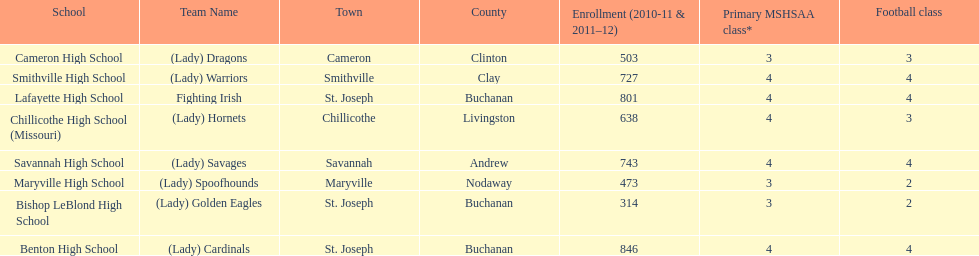Which school has the least amount of student enrollment between 2010-2011 and 2011-2012? Bishop LeBlond High School. 